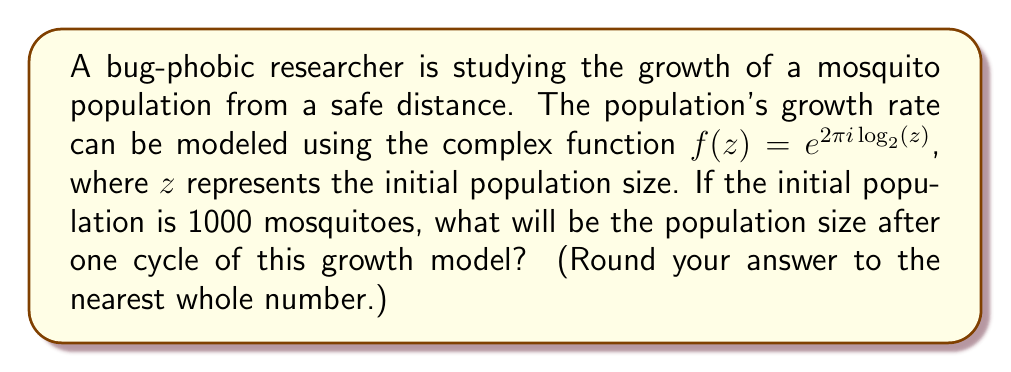Provide a solution to this math problem. Let's approach this step-by-step:

1) We're given the function $f(z) = e^{2\pi i \log_2(z)}$ and the initial population $z = 1000$.

2) We need to evaluate $f(1000)$:

   $f(1000) = e^{2\pi i \log_2(1000)}$

3) First, let's calculate $\log_2(1000)$:
   
   $1000 = 2^{9.96578428466209}$ (using a calculator)

   So, $\log_2(1000) \approx 9.96578428466209$

4) Now our function looks like:

   $f(1000) = e^{2\pi i (9.96578428466209)}$

5) Simplify the exponent:

   $2\pi i (9.96578428466209) \approx 62.61725123519331i$

6) Now we have:

   $f(1000) = e^{62.61725123519331i}$

7) Recall Euler's formula: $e^{ix} = \cos(x) + i\sin(x)$

   So, $f(1000) = \cos(62.61725123519331) + i\sin(62.61725123519331)$

8) Calculate:

   $\cos(62.61725123519331) \approx 0.9999999999999999$
   $\sin(62.61725123519331) \approx 1.2246467991473532 \times 10^{-16}$

9) Therefore:

   $f(1000) \approx 0.9999999999999999 + 1.2246467991473532 \times 10^{-16}i$

10) The magnitude of this complex number represents the new population size:

    $|f(1000)| = \sqrt{(0.9999999999999999)^2 + (1.2246467991473532 \times 10^{-16})^2} \approx 1$

11) Multiplying by the initial population:

    $1000 \times 1 = 1000$
Answer: 1000 mosquitoes 